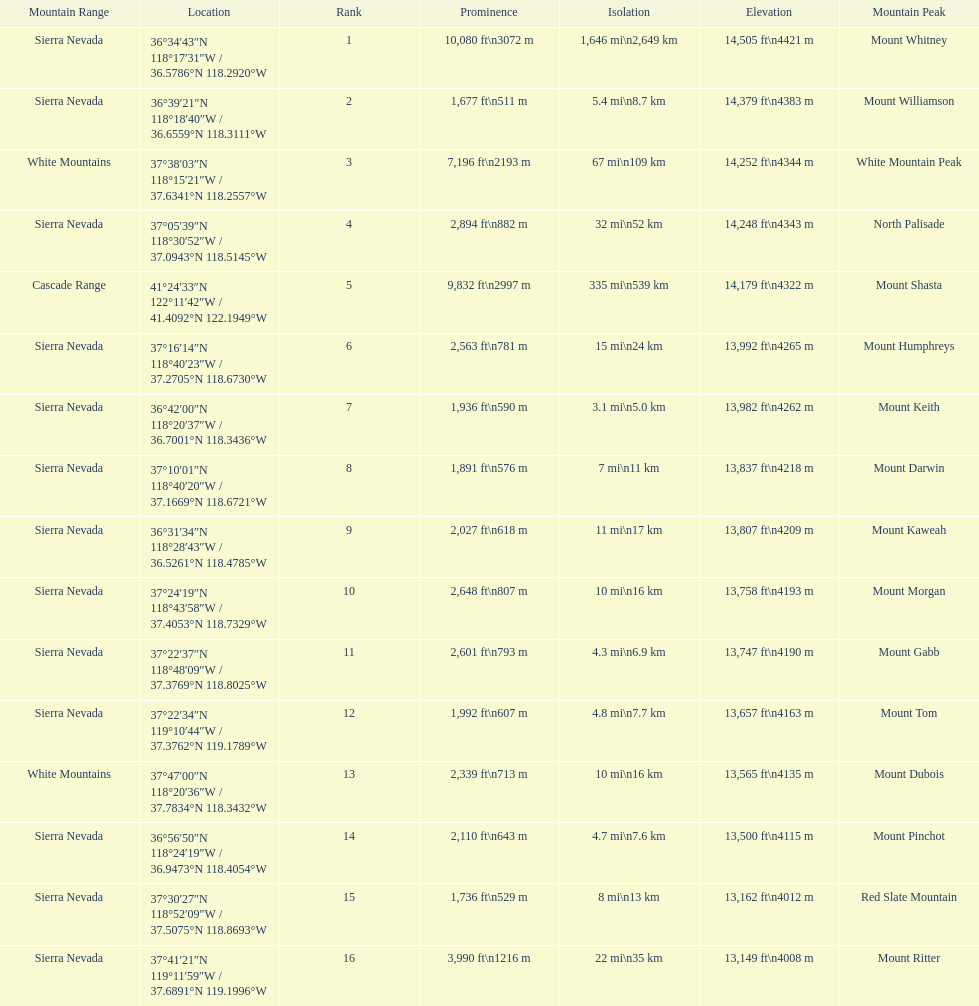Which mountain peak has the most isolation? Mount Whitney. 